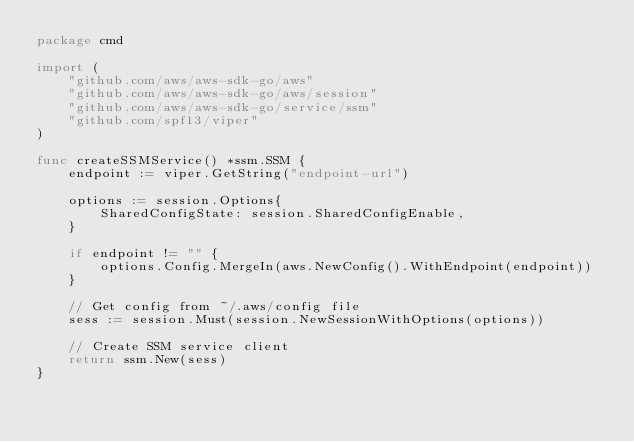Convert code to text. <code><loc_0><loc_0><loc_500><loc_500><_Go_>package cmd

import (
	"github.com/aws/aws-sdk-go/aws"
	"github.com/aws/aws-sdk-go/aws/session"
	"github.com/aws/aws-sdk-go/service/ssm"
	"github.com/spf13/viper"
)

func createSSMService() *ssm.SSM {
	endpoint := viper.GetString("endpoint-url")

	options := session.Options{
		SharedConfigState: session.SharedConfigEnable,
	}

	if endpoint != "" {
		options.Config.MergeIn(aws.NewConfig().WithEndpoint(endpoint))
	}

	// Get config from ~/.aws/config file
	sess := session.Must(session.NewSessionWithOptions(options))

	// Create SSM service client
	return ssm.New(sess)
}
</code> 